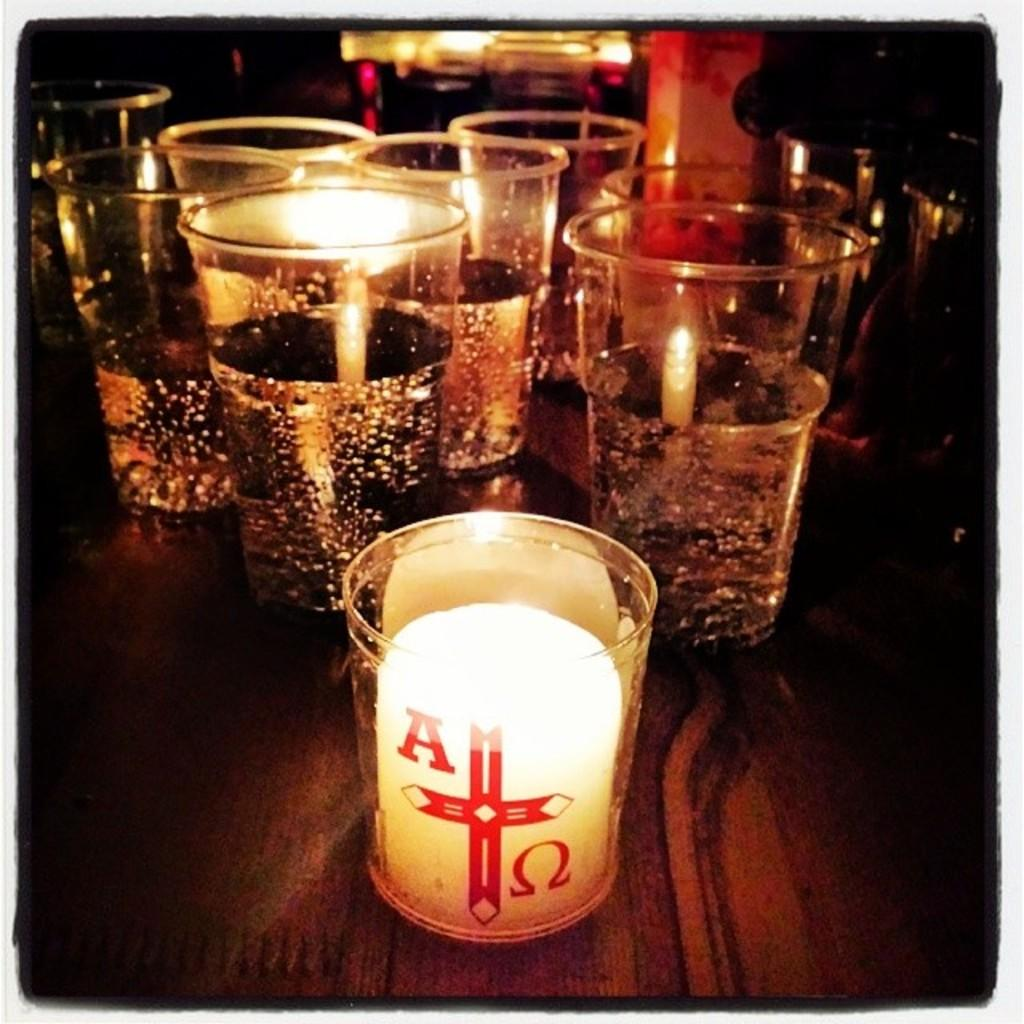<image>
Share a concise interpretation of the image provided. A bunch of glasses with closest one having a candle in it and the letter A on it. 